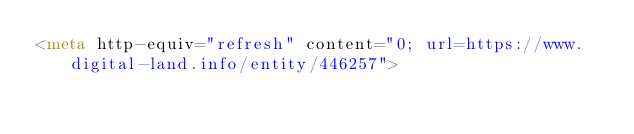<code> <loc_0><loc_0><loc_500><loc_500><_HTML_><meta http-equiv="refresh" content="0; url=https://www.digital-land.info/entity/446257"></code> 